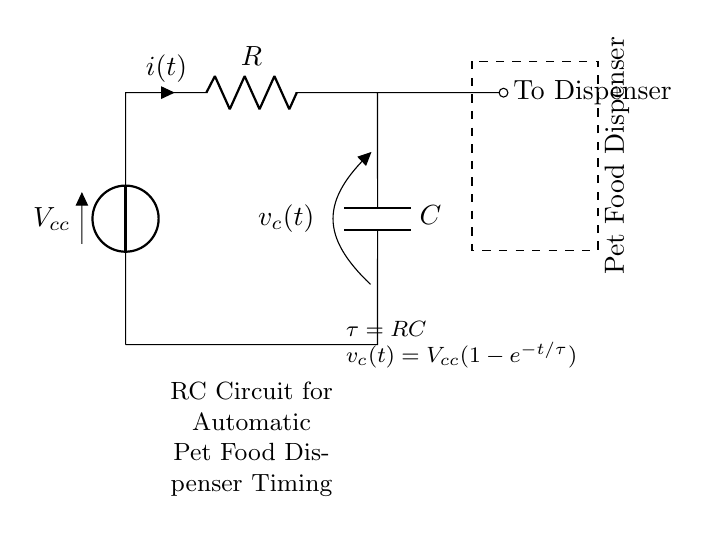What does R represent in the circuit? R represents the resistor in the circuit, which is responsible for limiting the current flow. You can see it labeled directly on the circuit diagram.
Answer: Resistor What is the unit of the capacitance C? The unit of capacitance is Farads (F). It's generally indicated near the capacitor symbol in the circuit; in this case, it is labeled as C.
Answer: Farads What is the time constant τ in this RC circuit? The time constant τ is calculated as the product of the resistance R and the capacitance C. It's shown in the diagram as τ = RC, which indicates how quickly the circuit responds to changes.
Answer: RC What happens to the voltage across the capacitor as time increases? The voltage across the capacitor increases exponentially over time until it reaches the supply voltage, as indicated by the voltage equation provided, where v_c(t) approaches V_cc as t approaches infinity.
Answer: Increases What is the purpose of this RC circuit in relation to the pet food dispenser? The purpose of the RC circuit is to control the timing of when the food dispenser operates, effectively creating a time delay before the dispenser releases food based on the charging of the capacitor.
Answer: Timing control 